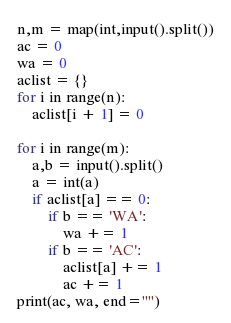<code> <loc_0><loc_0><loc_500><loc_500><_Python_>n,m = map(int,input().split())
ac = 0
wa = 0
aclist = {}
for i in range(n):
    aclist[i + 1] = 0

for i in range(m):
    a,b = input().split()
    a = int(a)
    if aclist[a] == 0:
        if b == 'WA':
            wa += 1
        if b == 'AC':
            aclist[a] += 1
            ac += 1
print(ac, wa, end="")</code> 